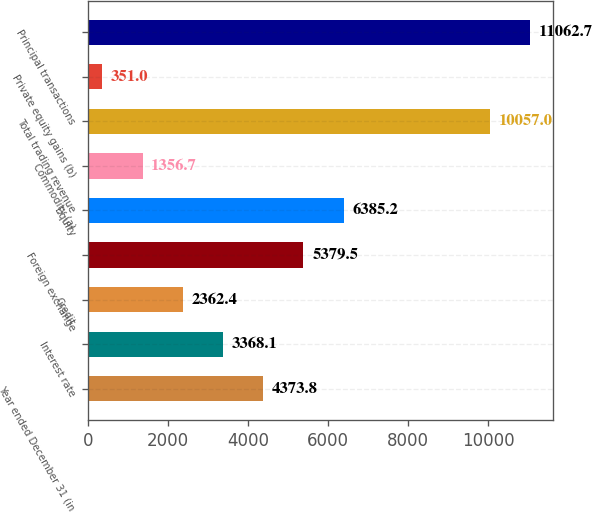Convert chart. <chart><loc_0><loc_0><loc_500><loc_500><bar_chart><fcel>Year ended December 31 (in<fcel>Interest rate<fcel>Credit<fcel>Foreign exchange<fcel>Equity<fcel>Commodity (a)<fcel>Total trading revenue<fcel>Private equity gains (b)<fcel>Principal transactions<nl><fcel>4373.8<fcel>3368.1<fcel>2362.4<fcel>5379.5<fcel>6385.2<fcel>1356.7<fcel>10057<fcel>351<fcel>11062.7<nl></chart> 